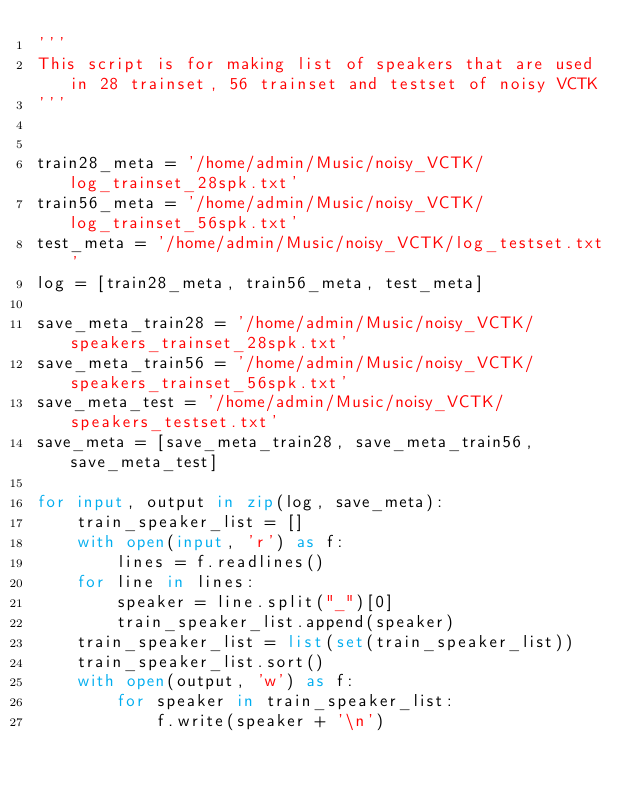Convert code to text. <code><loc_0><loc_0><loc_500><loc_500><_Python_>'''
This script is for making list of speakers that are used in 28 trainset, 56 trainset and testset of noisy VCTK
'''


train28_meta = '/home/admin/Music/noisy_VCTK/log_trainset_28spk.txt'
train56_meta = '/home/admin/Music/noisy_VCTK/log_trainset_56spk.txt'
test_meta = '/home/admin/Music/noisy_VCTK/log_testset.txt'
log = [train28_meta, train56_meta, test_meta]

save_meta_train28 = '/home/admin/Music/noisy_VCTK/speakers_trainset_28spk.txt'
save_meta_train56 = '/home/admin/Music/noisy_VCTK/speakers_trainset_56spk.txt'
save_meta_test = '/home/admin/Music/noisy_VCTK/speakers_testset.txt'
save_meta = [save_meta_train28, save_meta_train56, save_meta_test]

for input, output in zip(log, save_meta):
    train_speaker_list = []
    with open(input, 'r') as f:
        lines = f.readlines()
    for line in lines:
        speaker = line.split("_")[0]
        train_speaker_list.append(speaker)
    train_speaker_list = list(set(train_speaker_list))
    train_speaker_list.sort()
    with open(output, 'w') as f:
        for speaker in train_speaker_list:
            f.write(speaker + '\n')

</code> 